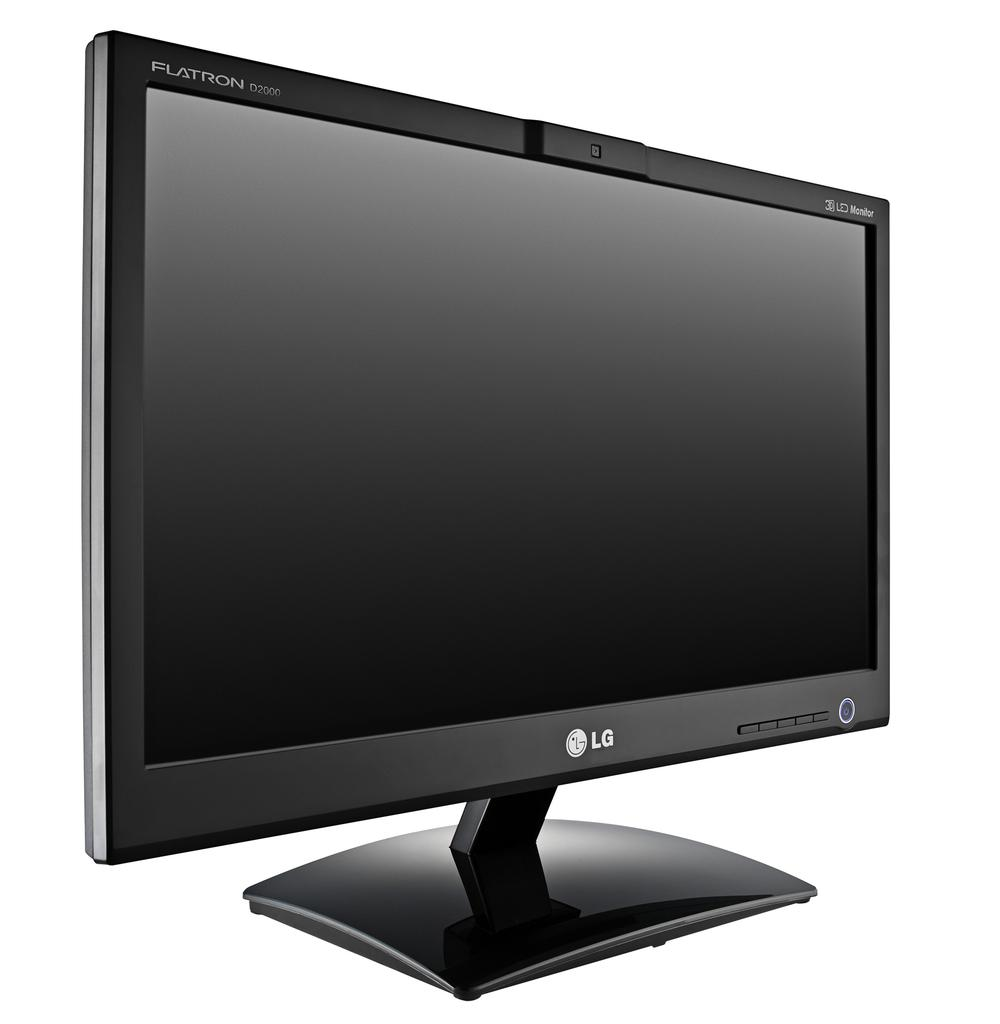Provide a one-sentence caption for the provided image. A black LG FLatron monitor with a white background. 